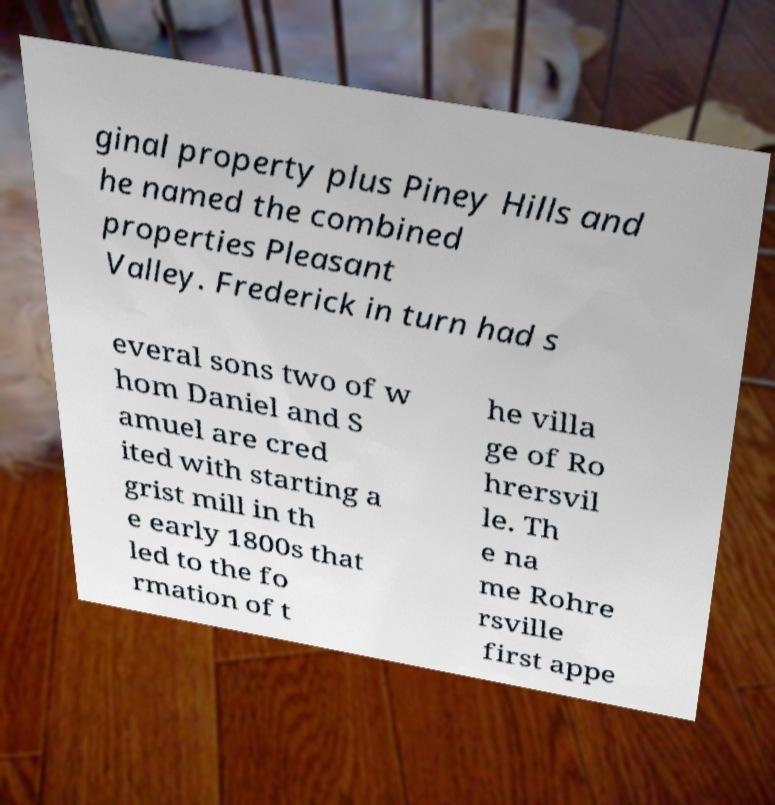Can you read and provide the text displayed in the image?This photo seems to have some interesting text. Can you extract and type it out for me? ginal property plus Piney Hills and he named the combined properties Pleasant Valley. Frederick in turn had s everal sons two of w hom Daniel and S amuel are cred ited with starting a grist mill in th e early 1800s that led to the fo rmation of t he villa ge of Ro hrersvil le. Th e na me Rohre rsville first appe 